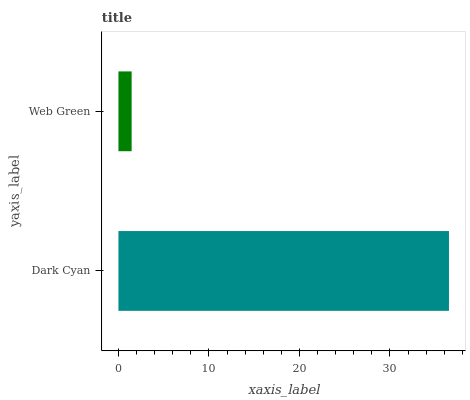Is Web Green the minimum?
Answer yes or no. Yes. Is Dark Cyan the maximum?
Answer yes or no. Yes. Is Web Green the maximum?
Answer yes or no. No. Is Dark Cyan greater than Web Green?
Answer yes or no. Yes. Is Web Green less than Dark Cyan?
Answer yes or no. Yes. Is Web Green greater than Dark Cyan?
Answer yes or no. No. Is Dark Cyan less than Web Green?
Answer yes or no. No. Is Dark Cyan the high median?
Answer yes or no. Yes. Is Web Green the low median?
Answer yes or no. Yes. Is Web Green the high median?
Answer yes or no. No. Is Dark Cyan the low median?
Answer yes or no. No. 